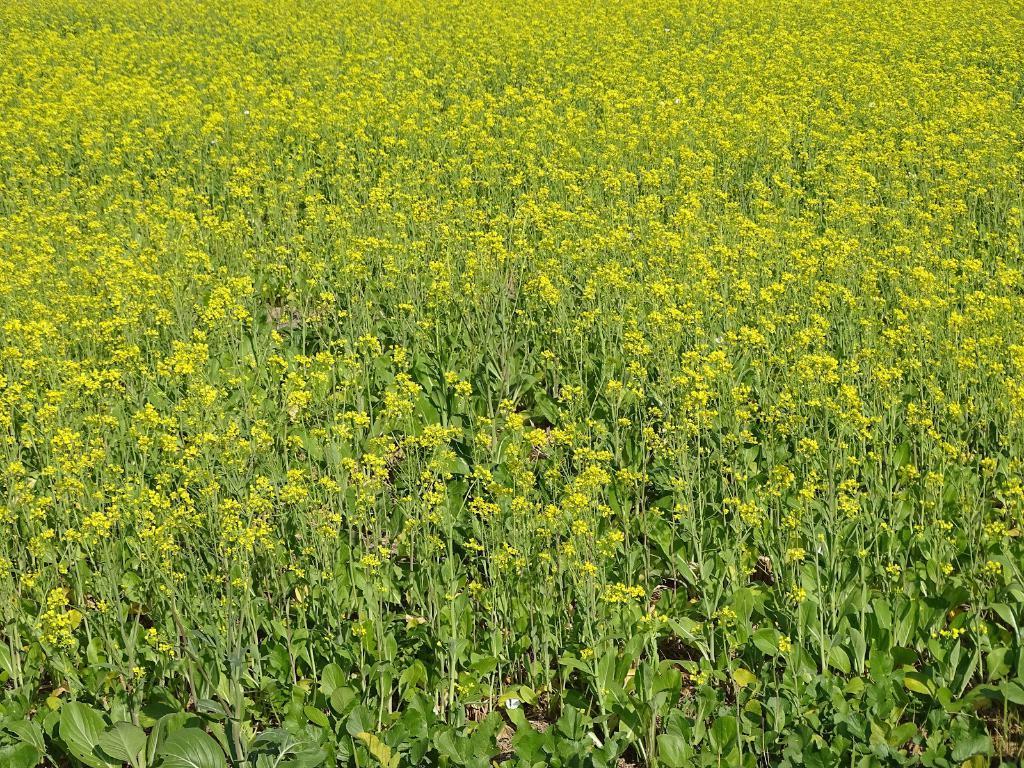How would you summarize this image in a sentence or two? In this picture I can see plants with flowers. 